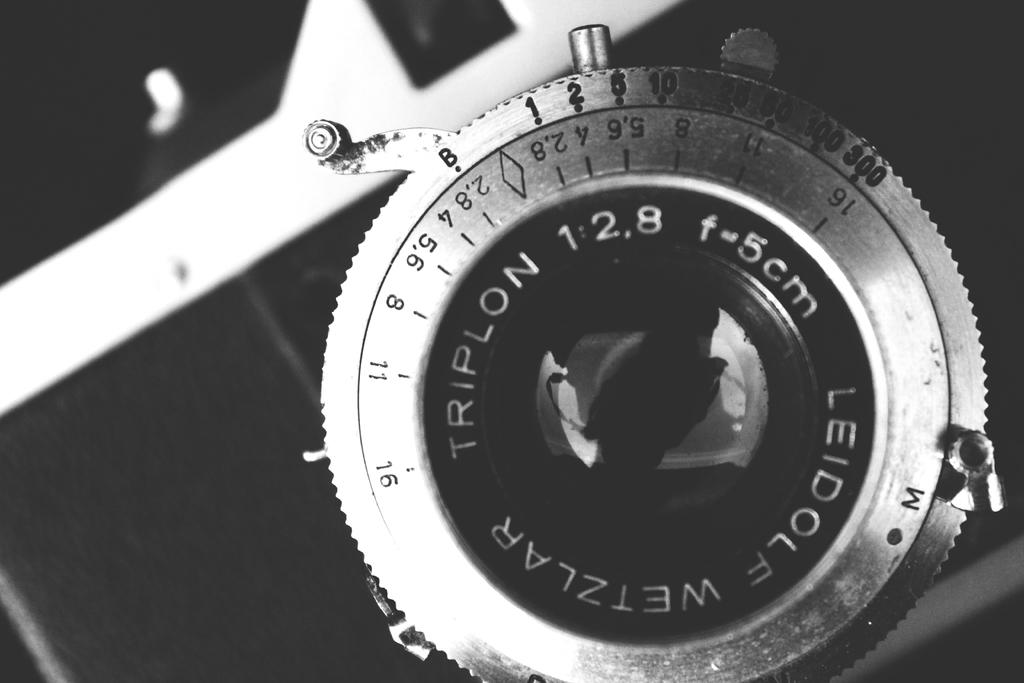What is the main subject of the picture? The main subject of the picture is a camera lens. Can you describe any text or writing on the camera lens? Yes, there is writing around the camera lens. Are there any additional markings on or near the camera lens? Yes, there are markings on or near the camera lens. What color is the camera lens in the picture? The camera is black in color. What type of plants can be seen growing near the camera lens in the image? There are no plants visible in the image; it only features a camera lens with writing and markings. Can you describe the root system of the plants near the camera lens in the image? There are no plants or roots present in the image, as it only features a camera lens. 